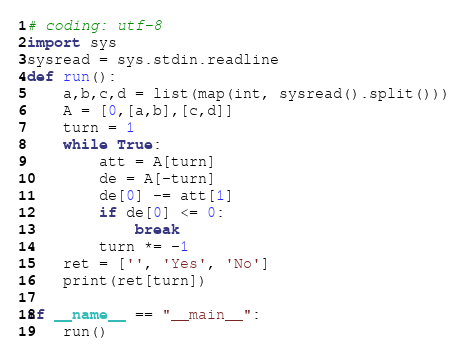Convert code to text. <code><loc_0><loc_0><loc_500><loc_500><_Python_># coding: utf-8
import sys
sysread = sys.stdin.readline
def run():
    a,b,c,d = list(map(int, sysread().split()))
    A = [0,[a,b],[c,d]]
    turn = 1
    while True:
        att = A[turn]
        de = A[-turn]
        de[0] -= att[1]
        if de[0] <= 0:
            break
        turn *= -1
    ret = ['', 'Yes', 'No']
    print(ret[turn])

if __name__ == "__main__":
    run()</code> 